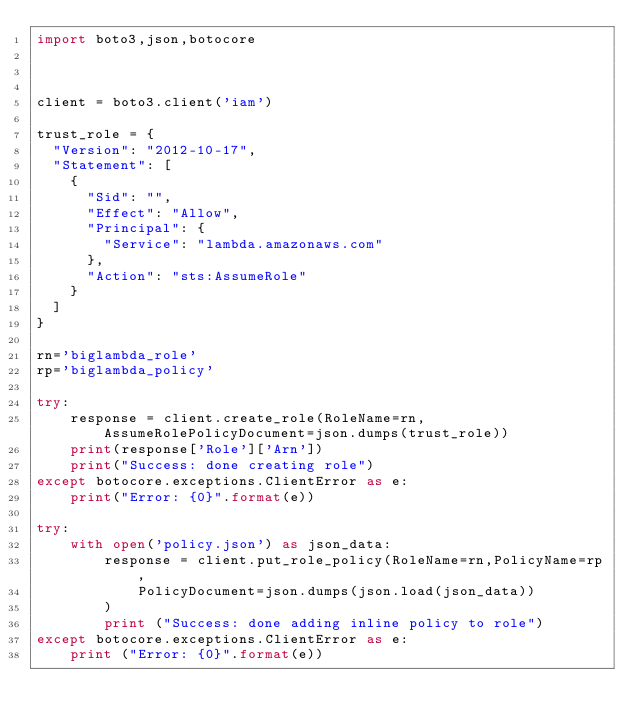<code> <loc_0><loc_0><loc_500><loc_500><_Python_>import boto3,json,botocore



client = boto3.client('iam')

trust_role = {
  "Version": "2012-10-17",
  "Statement": [
    {
      "Sid": "",
      "Effect": "Allow",
      "Principal": {
        "Service": "lambda.amazonaws.com"
      },
      "Action": "sts:AssumeRole"
    }
  ]
}

rn='biglambda_role'
rp='biglambda_policy'

try:
    response = client.create_role(RoleName=rn,AssumeRolePolicyDocument=json.dumps(trust_role))
    print(response['Role']['Arn'])
    print("Success: done creating role")
except botocore.exceptions.ClientError as e:
    print("Error: {0}".format(e))

try:
    with open('policy.json') as json_data:
        response = client.put_role_policy(RoleName=rn,PolicyName=rp,
            PolicyDocument=json.dumps(json.load(json_data))
        )
        print ("Success: done adding inline policy to role")
except botocore.exceptions.ClientError as e:
    print ("Error: {0}".format(e))


</code> 